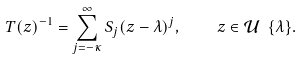Convert formula to latex. <formula><loc_0><loc_0><loc_500><loc_500>T ( z ) ^ { - 1 } = \sum _ { j = - \kappa } ^ { \infty } S _ { j } ( z - \lambda ) ^ { j } , \quad z \in \mathcal { U } \ \{ \lambda \} .</formula> 